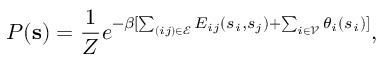Convert formula to latex. <formula><loc_0><loc_0><loc_500><loc_500>P ( s ) = \frac { 1 } { Z } e ^ { - \beta [ \sum _ { ( i j ) \in \mathcal { E } } E _ { i j } ( s _ { i } , s _ { j } ) + \sum _ { i \in \mathcal { V } } \theta _ { i } ( s _ { i } ) ] } ,</formula> 